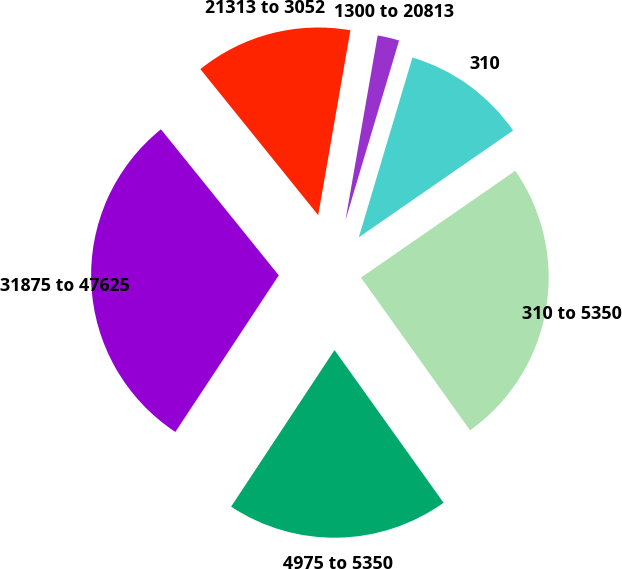Convert chart to OTSL. <chart><loc_0><loc_0><loc_500><loc_500><pie_chart><fcel>310<fcel>1300 to 20813<fcel>21313 to 3052<fcel>31875 to 47625<fcel>4975 to 5350<fcel>310 to 5350<nl><fcel>10.75%<fcel>1.87%<fcel>13.55%<fcel>29.91%<fcel>19.16%<fcel>24.77%<nl></chart> 